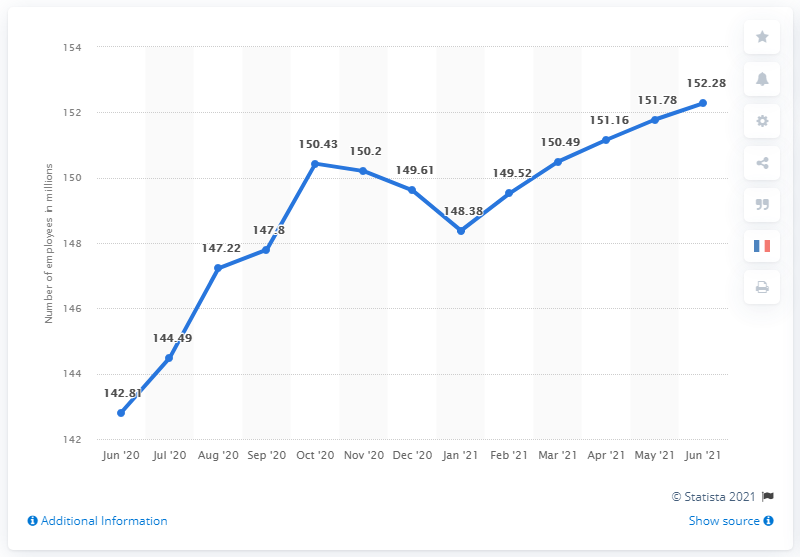Mention a couple of crucial points in this snapshot. In June 2021, there were 152.28 million people employed in the United States. 